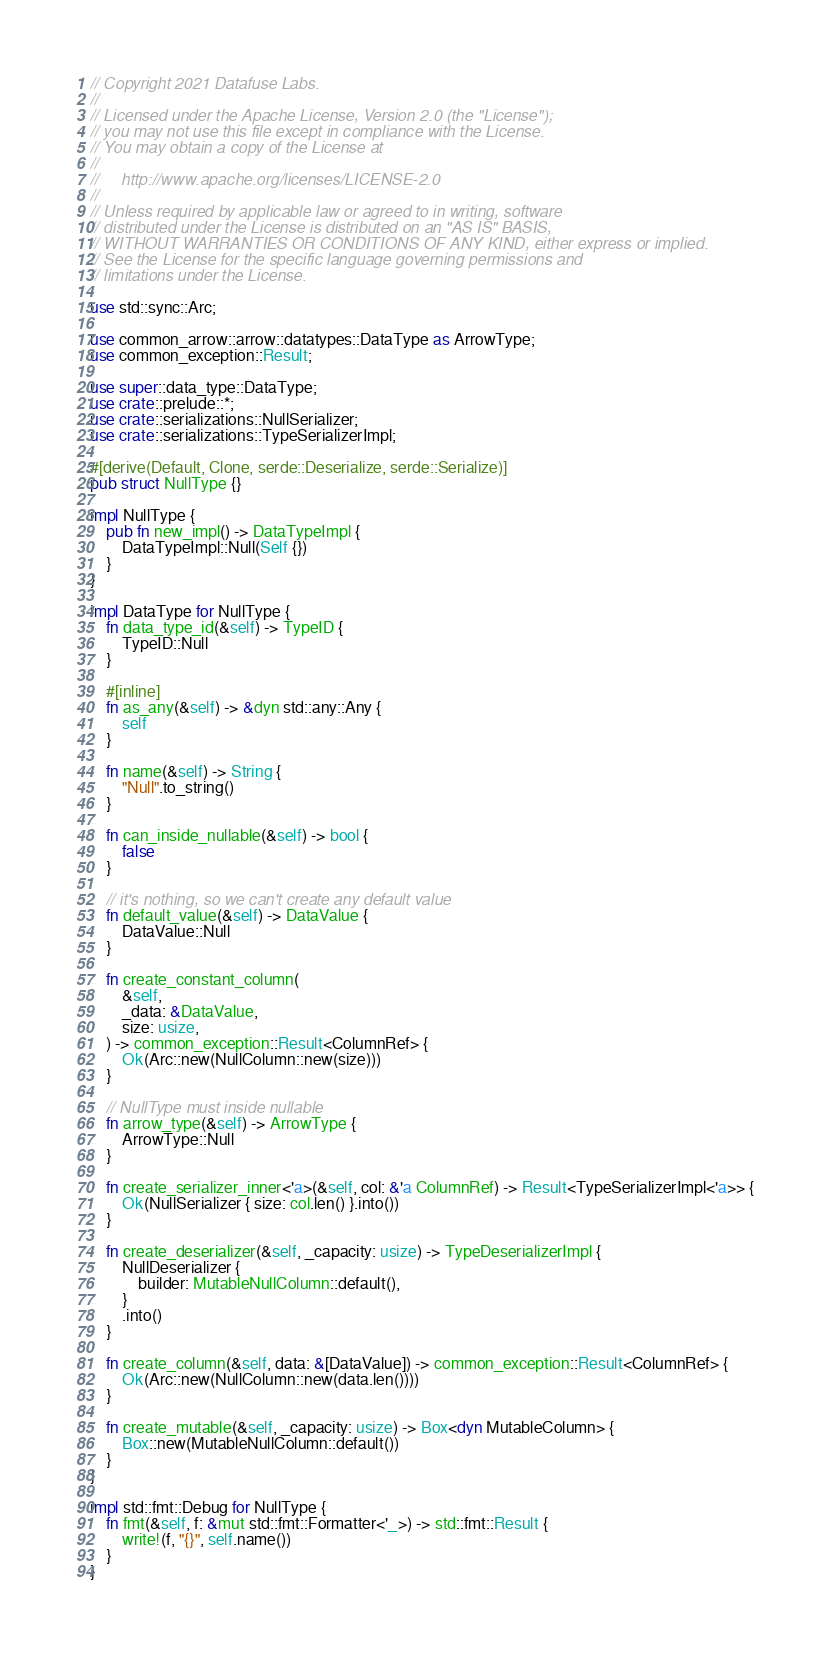<code> <loc_0><loc_0><loc_500><loc_500><_Rust_>// Copyright 2021 Datafuse Labs.
//
// Licensed under the Apache License, Version 2.0 (the "License");
// you may not use this file except in compliance with the License.
// You may obtain a copy of the License at
//
//     http://www.apache.org/licenses/LICENSE-2.0
//
// Unless required by applicable law or agreed to in writing, software
// distributed under the License is distributed on an "AS IS" BASIS,
// WITHOUT WARRANTIES OR CONDITIONS OF ANY KIND, either express or implied.
// See the License for the specific language governing permissions and
// limitations under the License.

use std::sync::Arc;

use common_arrow::arrow::datatypes::DataType as ArrowType;
use common_exception::Result;

use super::data_type::DataType;
use crate::prelude::*;
use crate::serializations::NullSerializer;
use crate::serializations::TypeSerializerImpl;

#[derive(Default, Clone, serde::Deserialize, serde::Serialize)]
pub struct NullType {}

impl NullType {
    pub fn new_impl() -> DataTypeImpl {
        DataTypeImpl::Null(Self {})
    }
}

impl DataType for NullType {
    fn data_type_id(&self) -> TypeID {
        TypeID::Null
    }

    #[inline]
    fn as_any(&self) -> &dyn std::any::Any {
        self
    }

    fn name(&self) -> String {
        "Null".to_string()
    }

    fn can_inside_nullable(&self) -> bool {
        false
    }

    // it's nothing, so we can't create any default value
    fn default_value(&self) -> DataValue {
        DataValue::Null
    }

    fn create_constant_column(
        &self,
        _data: &DataValue,
        size: usize,
    ) -> common_exception::Result<ColumnRef> {
        Ok(Arc::new(NullColumn::new(size)))
    }

    // NullType must inside nullable
    fn arrow_type(&self) -> ArrowType {
        ArrowType::Null
    }

    fn create_serializer_inner<'a>(&self, col: &'a ColumnRef) -> Result<TypeSerializerImpl<'a>> {
        Ok(NullSerializer { size: col.len() }.into())
    }

    fn create_deserializer(&self, _capacity: usize) -> TypeDeserializerImpl {
        NullDeserializer {
            builder: MutableNullColumn::default(),
        }
        .into()
    }

    fn create_column(&self, data: &[DataValue]) -> common_exception::Result<ColumnRef> {
        Ok(Arc::new(NullColumn::new(data.len())))
    }

    fn create_mutable(&self, _capacity: usize) -> Box<dyn MutableColumn> {
        Box::new(MutableNullColumn::default())
    }
}

impl std::fmt::Debug for NullType {
    fn fmt(&self, f: &mut std::fmt::Formatter<'_>) -> std::fmt::Result {
        write!(f, "{}", self.name())
    }
}
</code> 